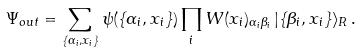Convert formula to latex. <formula><loc_0><loc_0><loc_500><loc_500>\Psi _ { o u t } = \sum _ { \{ \alpha _ { i } , { x } _ { i } \} } \psi ( \{ \alpha _ { i } , { x } _ { i } \} ) \prod _ { i } W ( { x } _ { i } ) _ { \alpha _ { i } \beta _ { i } } \, | \{ \beta _ { i } , { x } _ { i } \} \rangle _ { R } \, .</formula> 